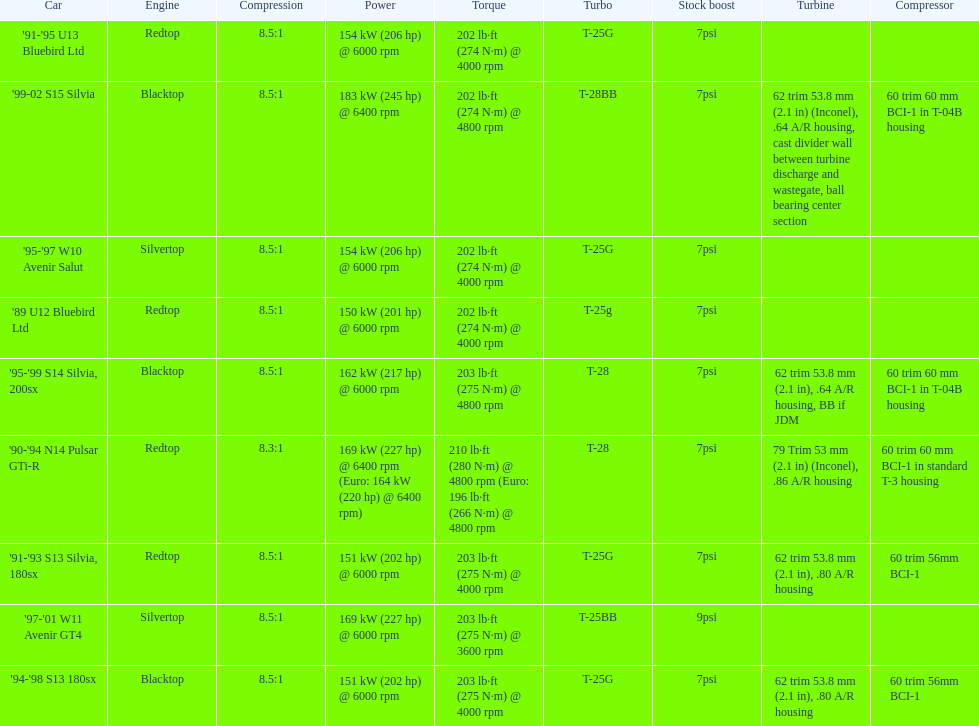What are the listed hp of the cars? 150 kW (201 hp) @ 6000 rpm, 154 kW (206 hp) @ 6000 rpm, 154 kW (206 hp) @ 6000 rpm, 169 kW (227 hp) @ 6000 rpm, 169 kW (227 hp) @ 6400 rpm (Euro: 164 kW (220 hp) @ 6400 rpm), 151 kW (202 hp) @ 6000 rpm, 151 kW (202 hp) @ 6000 rpm, 162 kW (217 hp) @ 6000 rpm, 183 kW (245 hp) @ 6400 rpm. Which is the only car with over 230 hp? '99-02 S15 Silvia. 